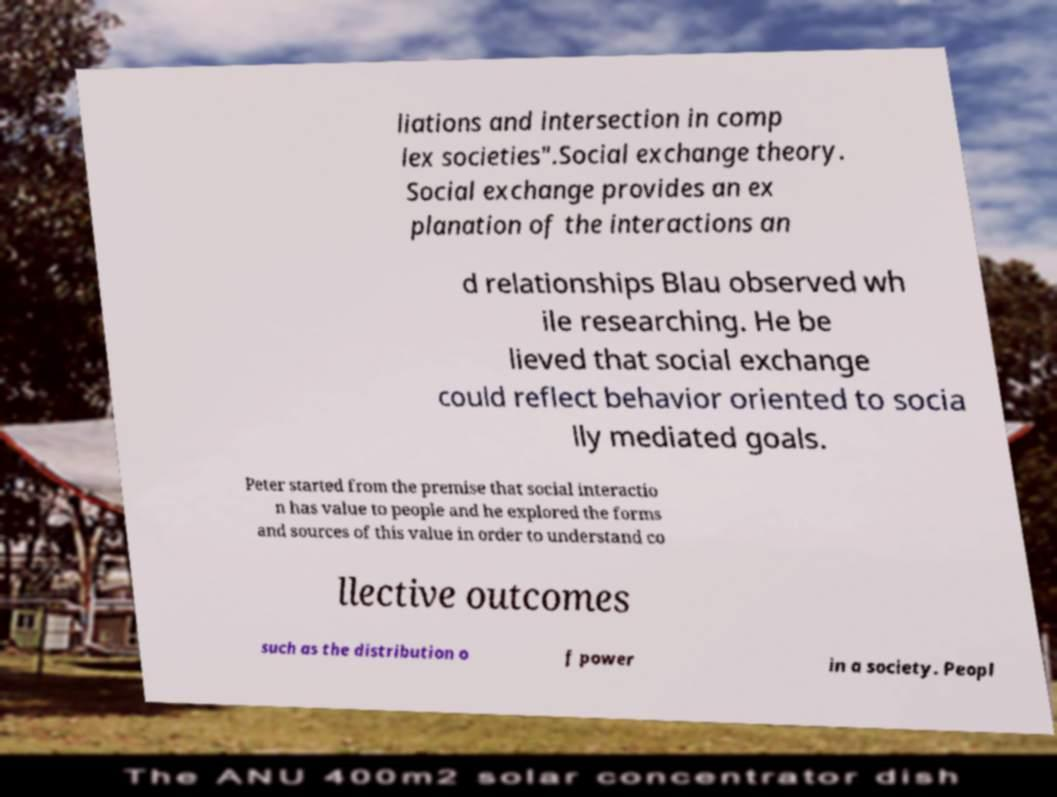I need the written content from this picture converted into text. Can you do that? liations and intersection in comp lex societies".Social exchange theory. Social exchange provides an ex planation of the interactions an d relationships Blau observed wh ile researching. He be lieved that social exchange could reflect behavior oriented to socia lly mediated goals. Peter started from the premise that social interactio n has value to people and he explored the forms and sources of this value in order to understand co llective outcomes such as the distribution o f power in a society. Peopl 